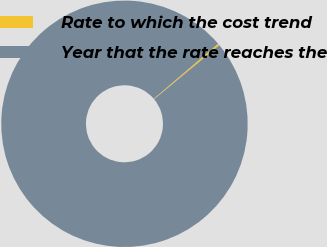<chart> <loc_0><loc_0><loc_500><loc_500><pie_chart><fcel>Rate to which the cost trend<fcel>Year that the rate reaches the<nl><fcel>0.25%<fcel>99.75%<nl></chart> 